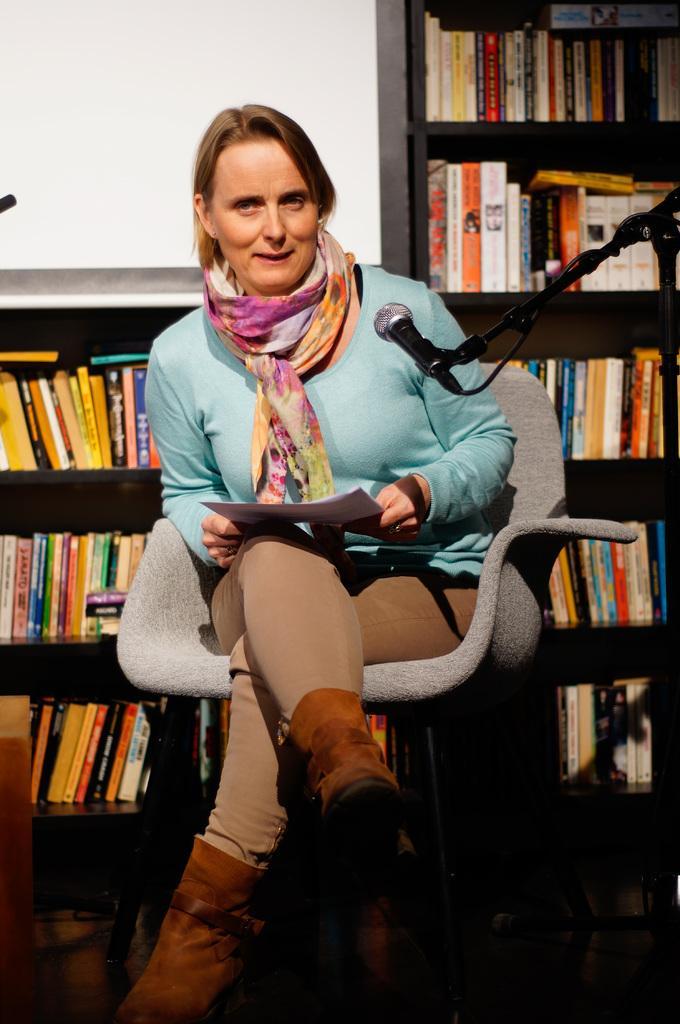Describe this image in one or two sentences. In the front of the image I can see a person is sitting on the chair and holding papers. In-front of that person there is a mic and mic stand. In the background of the image there is a wall and racks. In that racks there are books. 